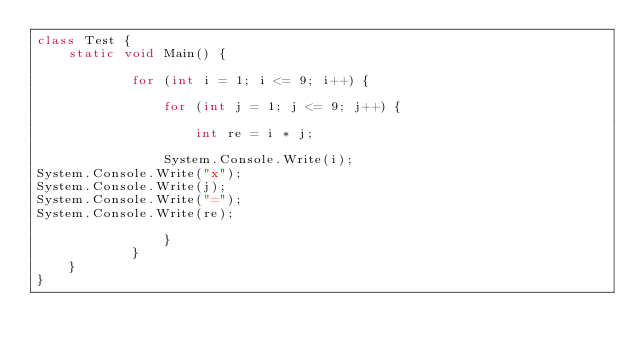Convert code to text. <code><loc_0><loc_0><loc_500><loc_500><_C#_>class Test {
    static void Main() {
 
            for (int i = 1; i <= 9; i++) {
 
                for (int j = 1; j <= 9; j++) {
 
                    int re = i * j;
 
                System.Console.Write(i);
System.Console.Write("x");
System.Console.Write(j);
System.Console.Write("=");
System.Console.Write(re);
 
                }
            }
    }
}</code> 